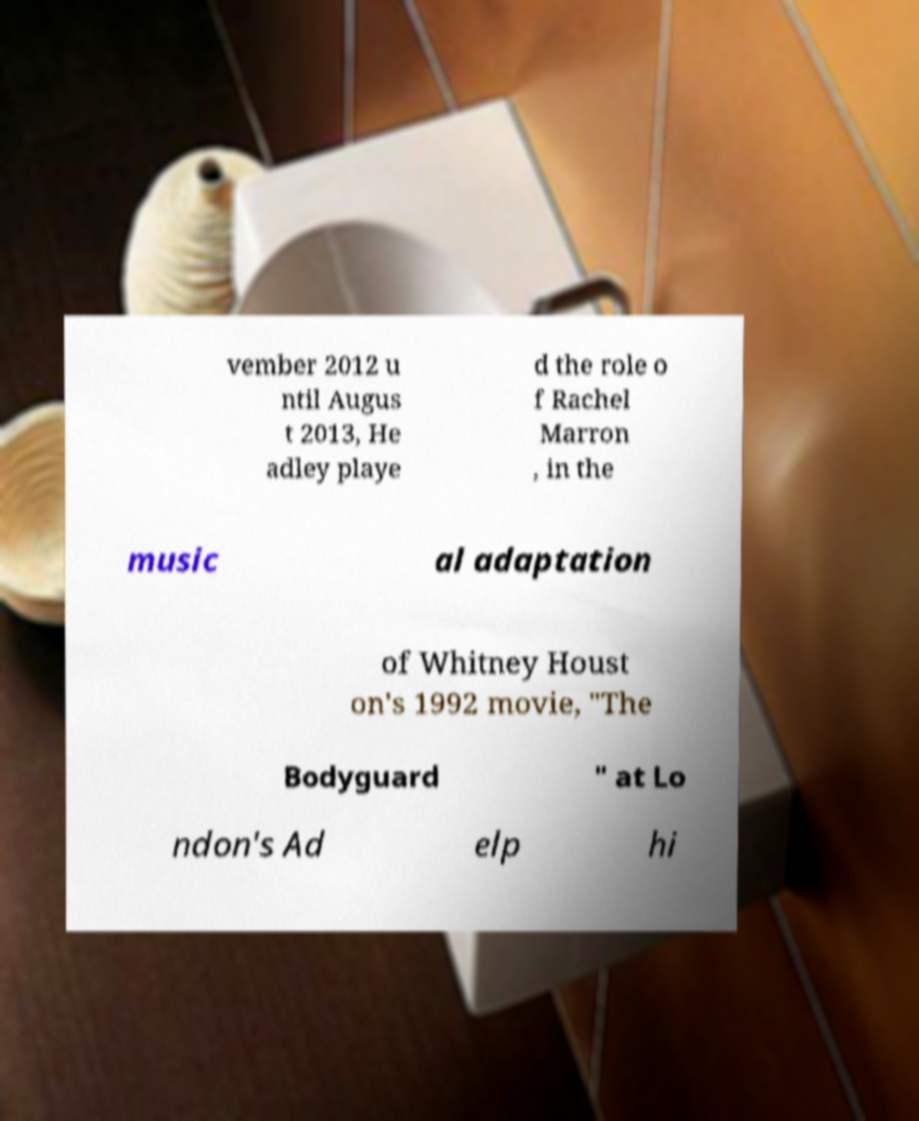Can you read and provide the text displayed in the image?This photo seems to have some interesting text. Can you extract and type it out for me? vember 2012 u ntil Augus t 2013, He adley playe d the role o f Rachel Marron , in the music al adaptation of Whitney Houst on's 1992 movie, "The Bodyguard " at Lo ndon's Ad elp hi 